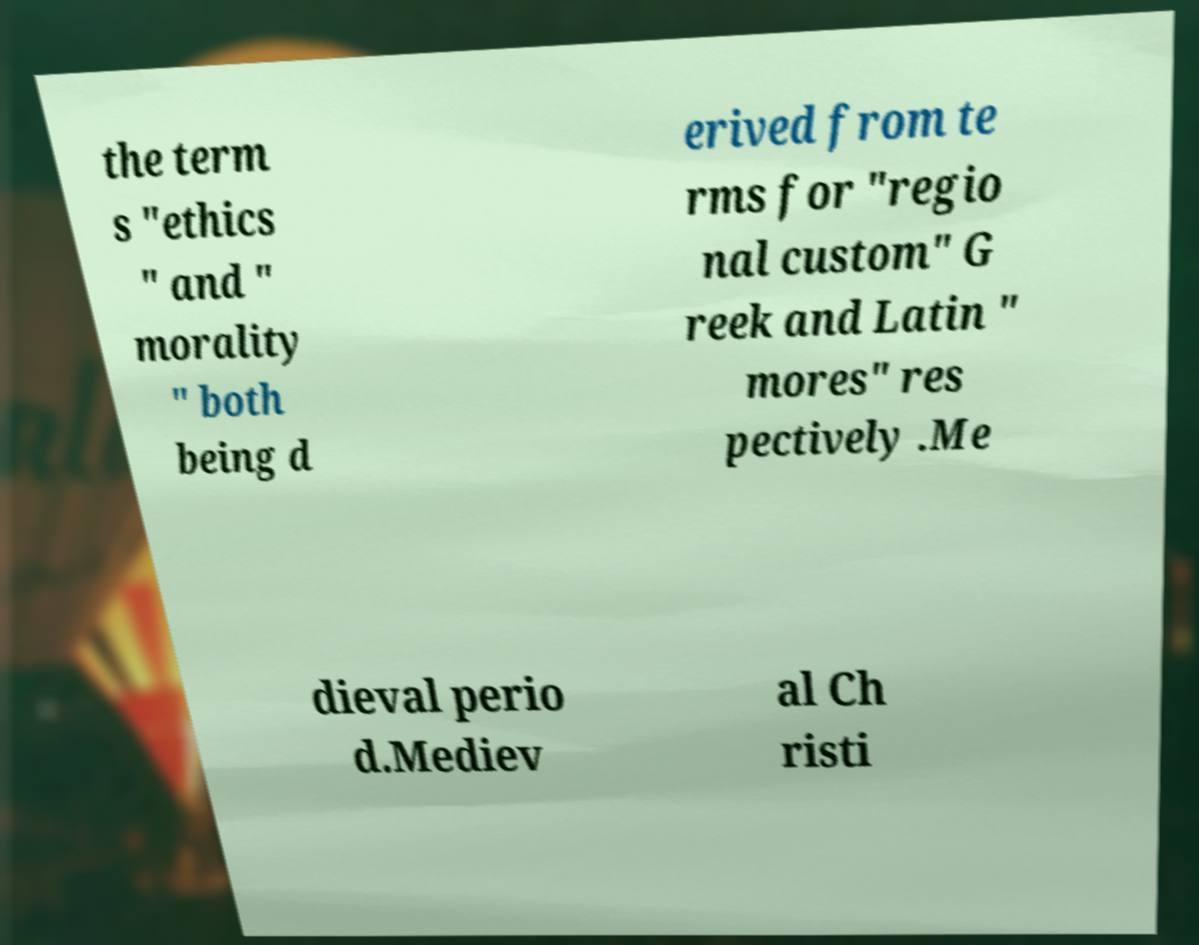For documentation purposes, I need the text within this image transcribed. Could you provide that? the term s "ethics " and " morality " both being d erived from te rms for "regio nal custom" G reek and Latin " mores" res pectively .Me dieval perio d.Mediev al Ch risti 